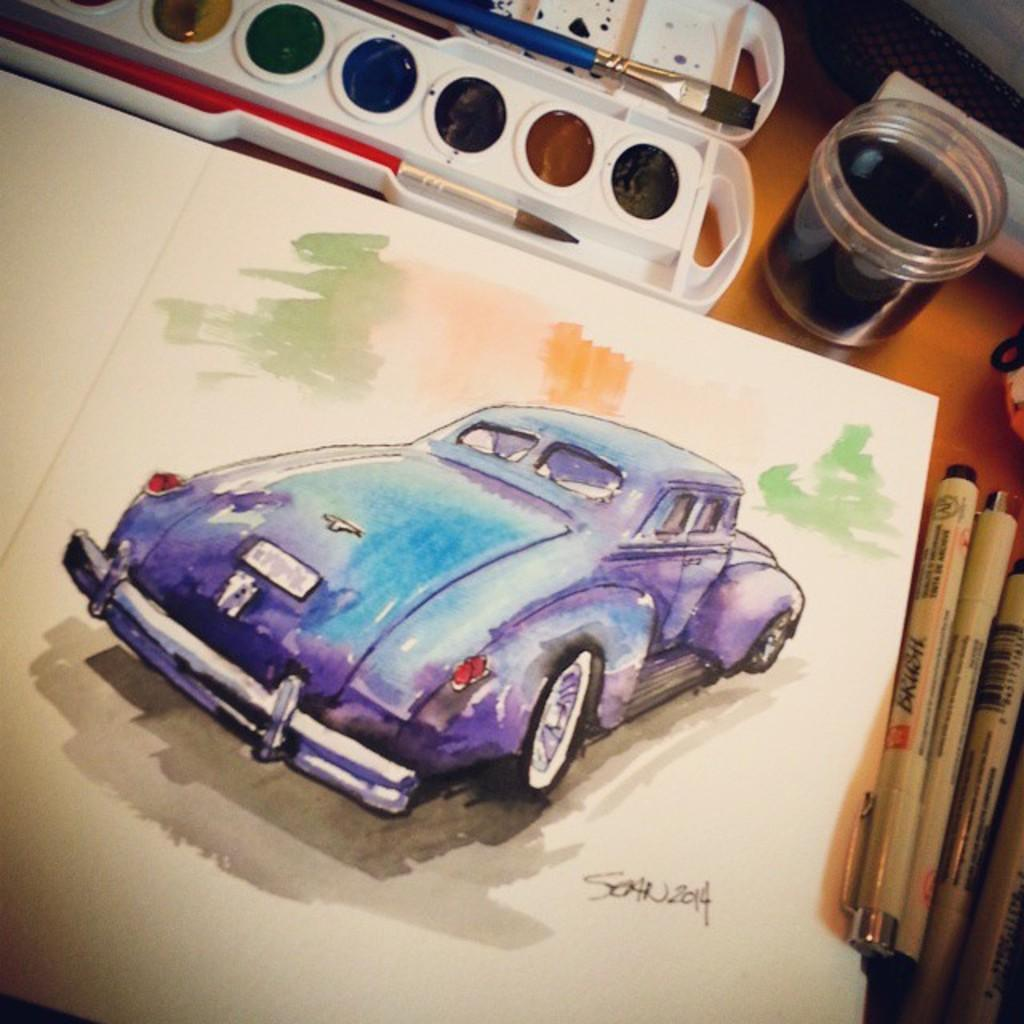What is the primary material of the surface in the foreground of the image? The surface in the foreground of the image is made of wood. What items can be seen on the wooden surface? There are pens, a paper, brushes, colors, a container, and additional objects on the wooden surface. What might be used for writing or drawing on the paper? The pens and brushes on the wooden surface could be used for writing or drawing on the paper. What is the container used for on the wooden surface? The purpose of the container on the wooden surface is not specified, but it could be used for holding colors, pens, or other items. What type of quartz is present on the wooden surface in the image? There is no quartz present on the wooden surface in the image. How does the lead interact with the wooden surface in the image? There is no lead present on the wooden surface in the image. 